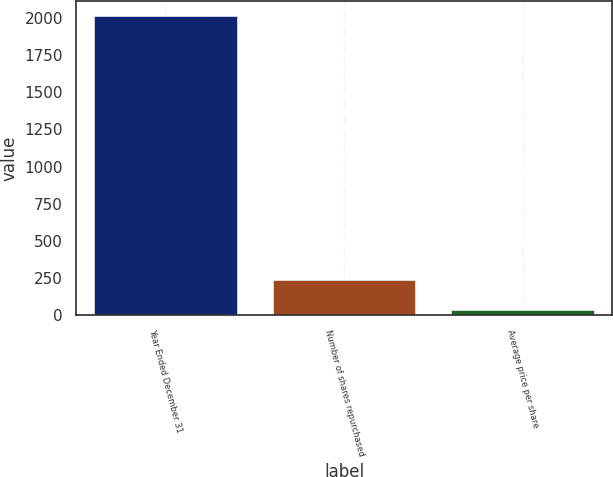<chart> <loc_0><loc_0><loc_500><loc_500><bar_chart><fcel>Year Ended December 31<fcel>Number of shares repurchased<fcel>Average price per share<nl><fcel>2012<fcel>234.6<fcel>37.11<nl></chart> 